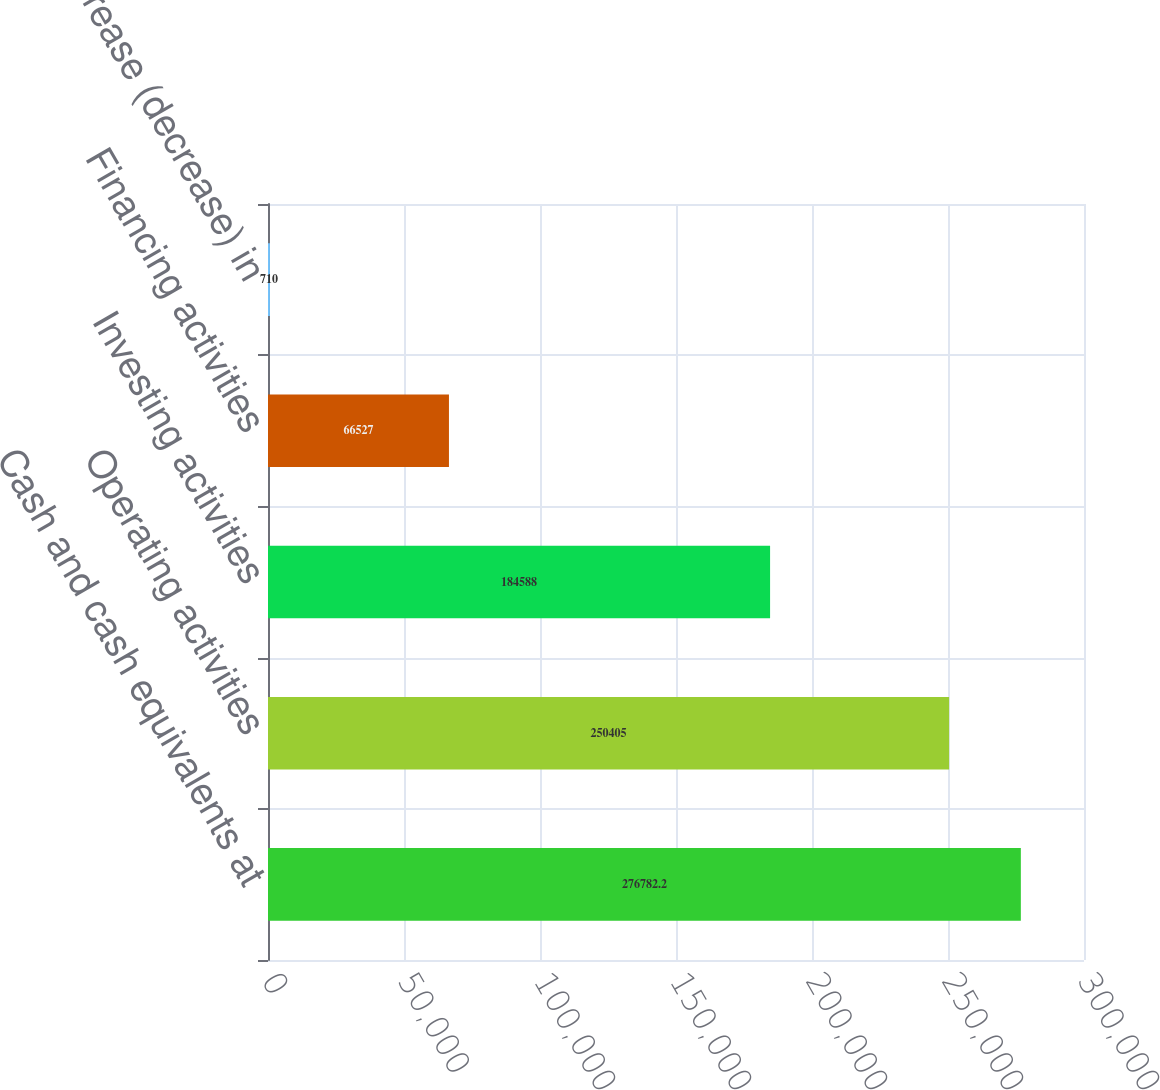<chart> <loc_0><loc_0><loc_500><loc_500><bar_chart><fcel>Cash and cash equivalents at<fcel>Operating activities<fcel>Investing activities<fcel>Financing activities<fcel>Net increase (decrease) in<nl><fcel>276782<fcel>250405<fcel>184588<fcel>66527<fcel>710<nl></chart> 